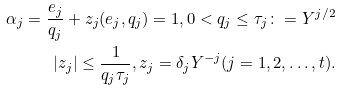<formula> <loc_0><loc_0><loc_500><loc_500>\alpha _ { j } = \frac { e _ { j } } { q _ { j } } + z _ { j } ( e _ { j } , q _ { j } ) = 1 , 0 < q _ { j } \leq \tau _ { j } \colon = Y ^ { j / 2 } \\ | z _ { j } | \leq \frac { 1 } { q _ { j } \tau _ { j } } , z _ { j } = \delta _ { j } Y ^ { - j } ( j = 1 , 2 , \dots , t ) .</formula> 